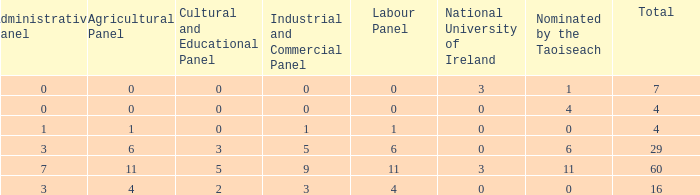What is the typical administrative committee of the composition designated by taoiseach 0 times with a total under 4? None. 